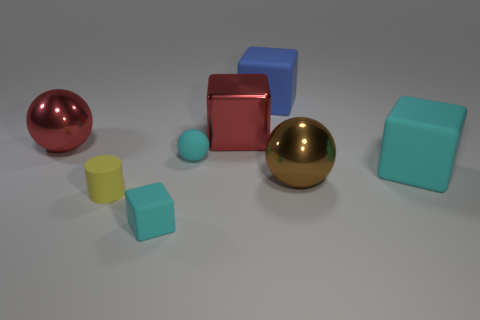What number of large cubes are right of the red cube and on the left side of the big brown ball?
Your answer should be very brief. 1. There is a tiny rubber thing that is the same color as the small ball; what shape is it?
Your answer should be compact. Cube. Does the big red ball have the same material as the yellow thing?
Offer a very short reply. No. What shape is the cyan rubber thing on the right side of the large shiny ball that is in front of the big shiny sphere on the left side of the tiny cyan cube?
Your answer should be very brief. Cube. Are there fewer large spheres that are on the right side of the yellow cylinder than metallic things that are in front of the large red cube?
Keep it short and to the point. Yes. What shape is the cyan matte object that is in front of the cyan rubber cube that is behind the yellow cylinder?
Offer a terse response. Cube. Is there any other thing of the same color as the tiny cube?
Make the answer very short. Yes. Do the small sphere and the tiny rubber cube have the same color?
Your answer should be very brief. Yes. How many yellow objects are matte cylinders or big metallic objects?
Your answer should be compact. 1. Are there fewer cyan matte objects in front of the yellow cylinder than red objects?
Offer a terse response. Yes. 